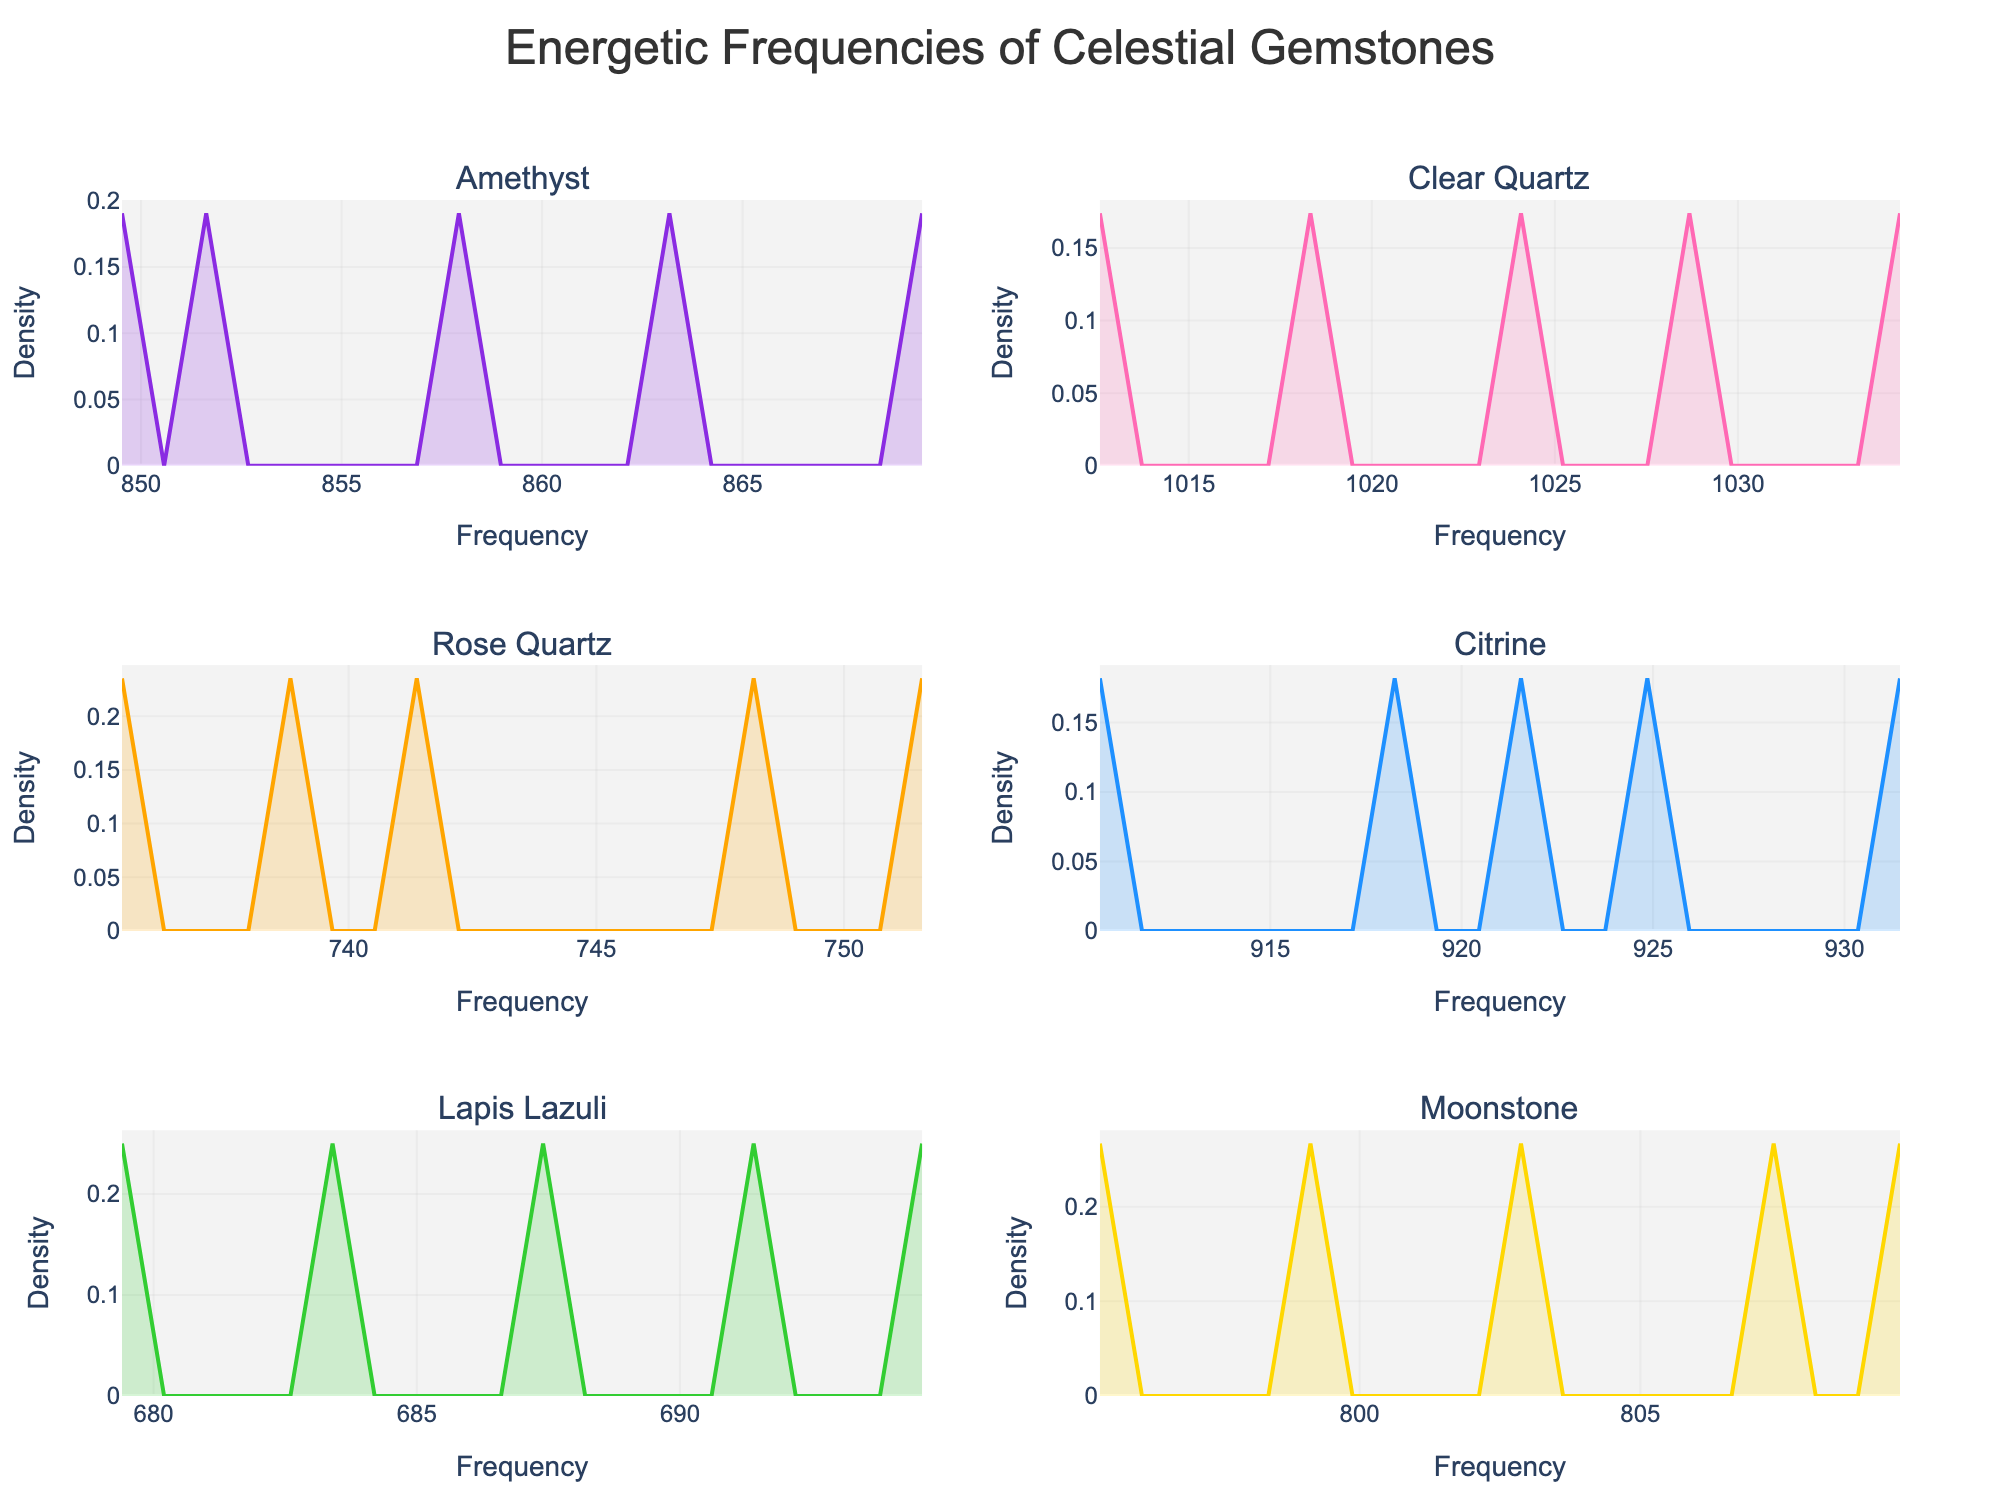What is the overall title of the figure? The title is positioned at the top of the figure. It reads "Energetic Frequencies of Celestial Gemstones".
Answer: Energetic Frequencies of Celestial Gemstones How many gemstones are displayed in the figure? The subplot titles indicate the different gemstones. Counting these titles, there are six gemstones displayed in the figure.
Answer: Six What color represents Amethyst in the density plot? The first subplot represents Amethyst. Observing the color of the density plot in this subplot, it is a shade of purple.
Answer: Purple Which gemstone has the highest peak in its density plot? To determine this, observe the height of the peaks in all the subplots. The subplot for Clear Quartz has the highest density peak.
Answer: Clear Quartz What is the range of frequencies for Rose Quartz? Look at the x-axis range in the subplot for Rose Quartz. The frequencies roughly lie between 735 and 752.
Answer: 735 to 752 Which gemstone's density distribution covers the widest range? Observing the x-axes of all subplots, Clear Quartz spans from approximately 1012 to 1035, which is the widest range among the gemstones.
Answer: Clear Quartz Compare the central frequency value for Amethyst and Moonstone. Which one is higher? The central value (mean) can be estimated by looking at the middle of the range for each subplot. For Amethyst, it's around 859.5, and for Moonstone, it's around 802. Hence, Amethyst has a higher central frequency.
Answer: Amethyst What is the general shape of the density plot for Lapis Lazuli? The density plot for Lapis Lazuli shows a symmetric, bell-like curve, indicating a normal distribution.
Answer: Symmetrical and bell-shaped Which gemstone displays the most symmetric density plot? The symmetry can be judged by how even the peaks are around the central frequency. Lapis Lazuli has a symmetric bell curve.
Answer: Lapis Lazuli 